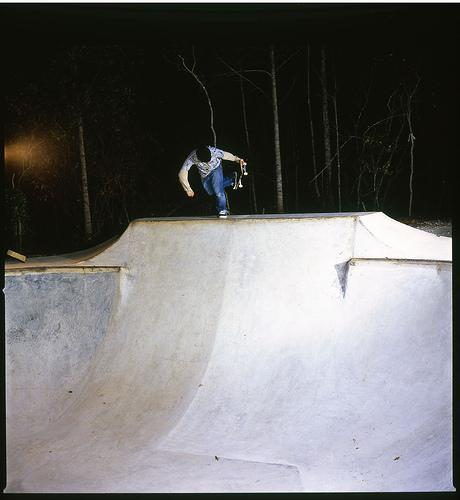Question: what is the man riding?
Choices:
A. A scooter.
B. A bike.
C. A skateboard.
D. A longboard.
Answer with the letter. Answer: C Question: how is the man getting around?
Choices:
A. A bicycle.
B. A skateboard.
C. A longboard.
D. He is walking.
Answer with the letter. Answer: B Question: when was this taken?
Choices:
A. During the day.
B. During the morning.
C. During dusk.
D. At night.
Answer with the letter. Answer: D Question: who is seen here?
Choices:
A. A skateboarder.
B. President.
C. Surfers.
D. Actors.
Answer with the letter. Answer: A Question: what is the man doing?
Choices:
A. Skateboarding.
B. Surfing.
C. Sleeping.
D. Eating.
Answer with the letter. Answer: A Question: why is the man on the ramp?
Choices:
A. Handicapped.
B. Easier than stairs.
C. He is skateboarding.
D. Bicycling.
Answer with the letter. Answer: C Question: where was this taken?
Choices:
A. Airport.
B. The mall.
C. The zoo.
D. At a skatepark.
Answer with the letter. Answer: D 